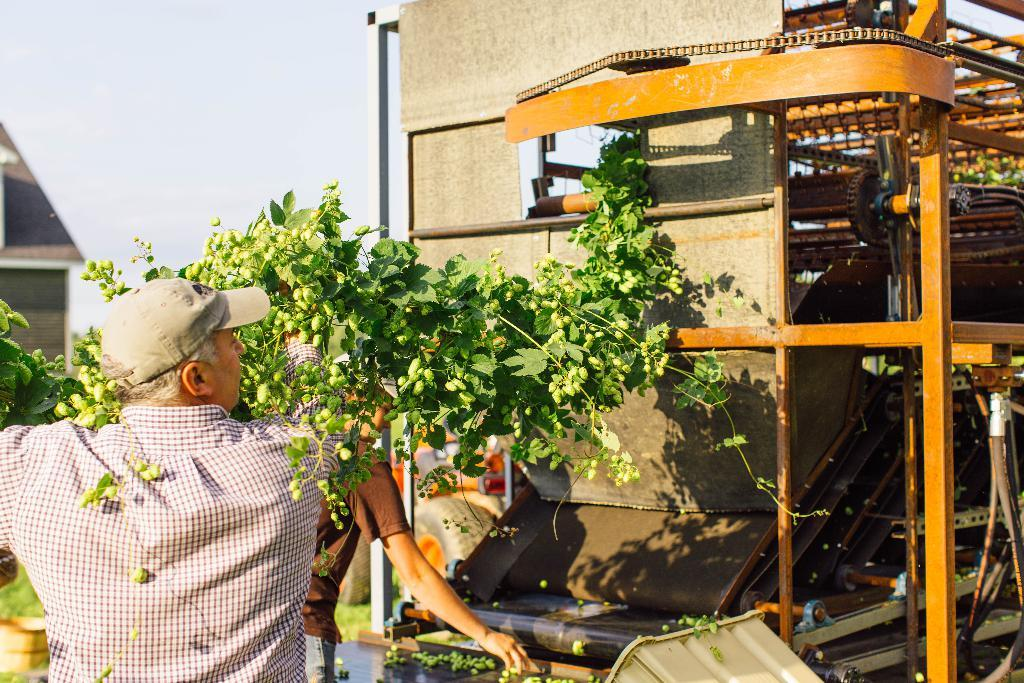What can be seen on the right side of the image? There is a machine on the right side of the image. Who is present near the machine? Two persons are standing near the machine. Can you describe the attire of one of the persons? One person is wearing a cap. What is the person wearing a cap holding? The person wearing a cap is holding a creeper. What is visible in the background of the image? The sky is visible in the background of the image. Where is the guide's nest located in the image? There is no guide or nest present in the image. What type of nerve can be seen in the person's hand in the image? There is no nerve visible in the image; the person is holding a creeper. 